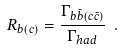<formula> <loc_0><loc_0><loc_500><loc_500>R _ { b ( c ) } = \frac { \Gamma _ { b \bar { b } ( c \bar { c } ) } } { \Gamma _ { h a d } } \ .</formula> 